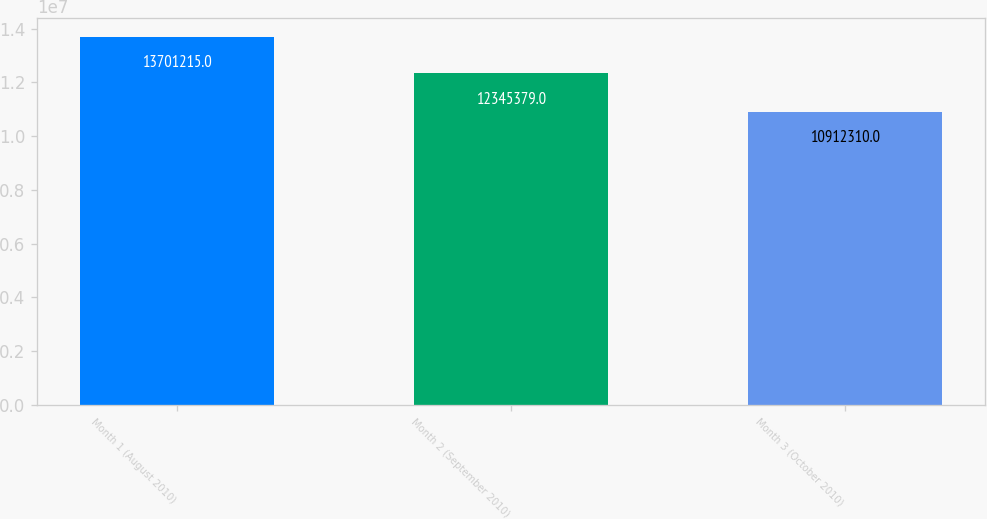Convert chart. <chart><loc_0><loc_0><loc_500><loc_500><bar_chart><fcel>Month 1 (August 2010)<fcel>Month 2 (September 2010)<fcel>Month 3 (October 2010)<nl><fcel>1.37012e+07<fcel>1.23454e+07<fcel>1.09123e+07<nl></chart> 